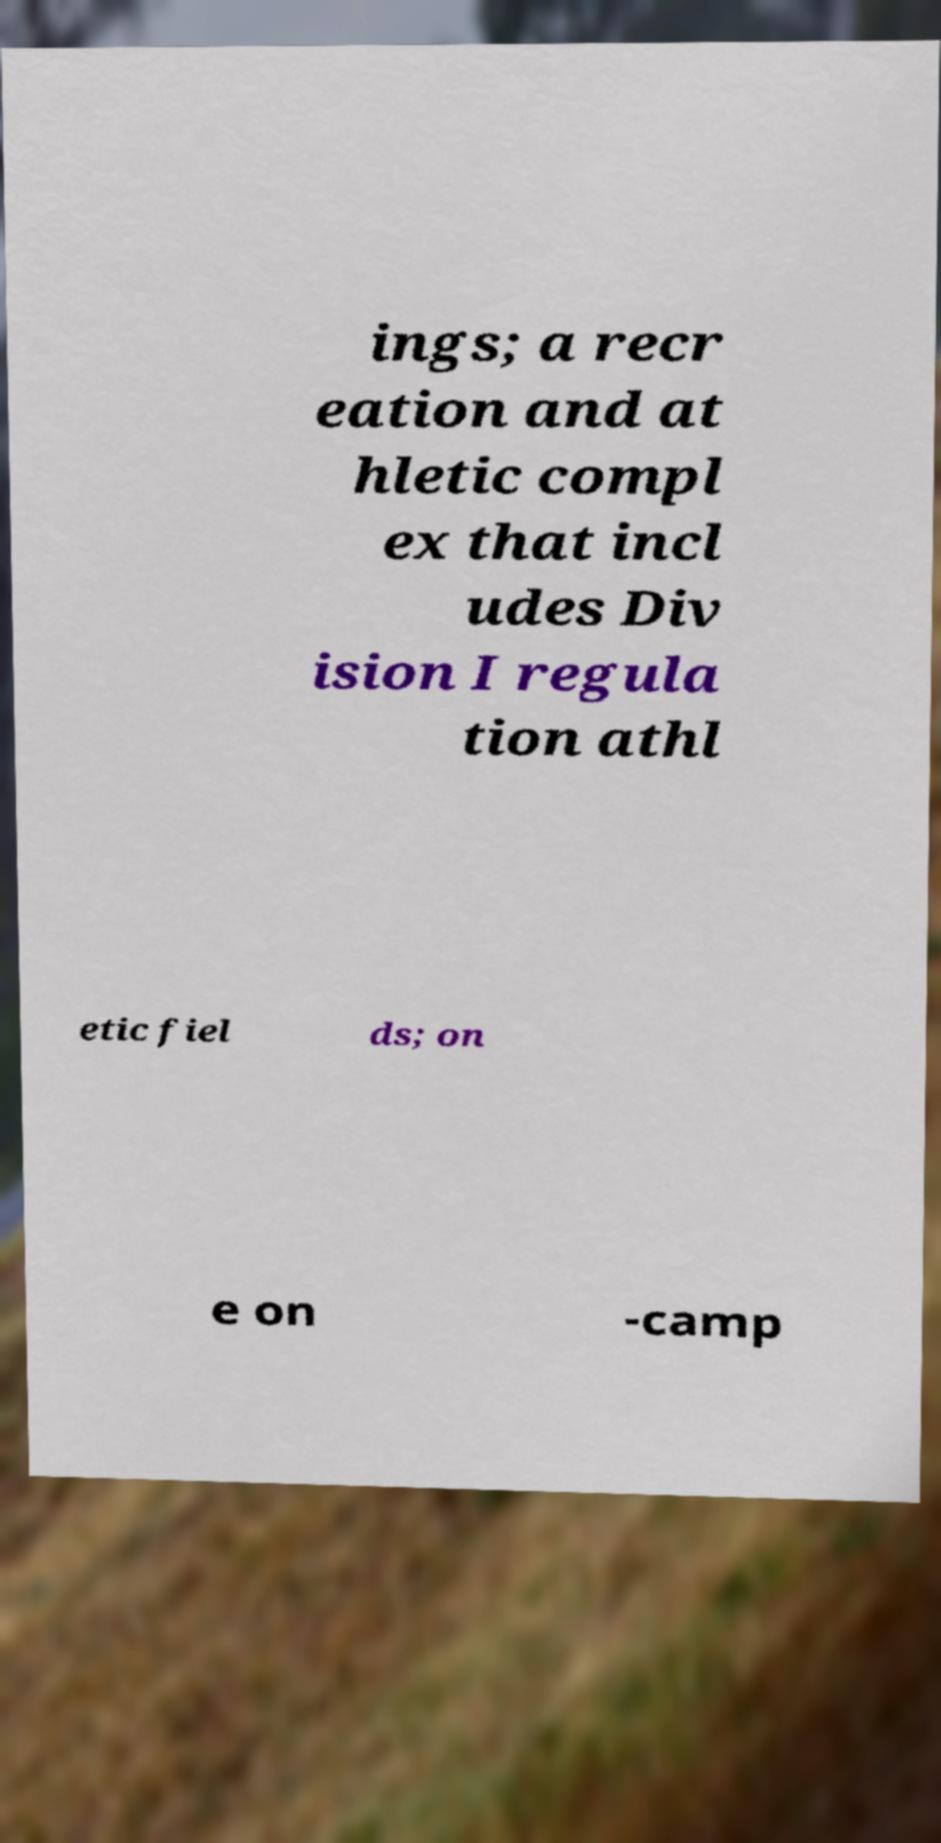Please identify and transcribe the text found in this image. ings; a recr eation and at hletic compl ex that incl udes Div ision I regula tion athl etic fiel ds; on e on -camp 